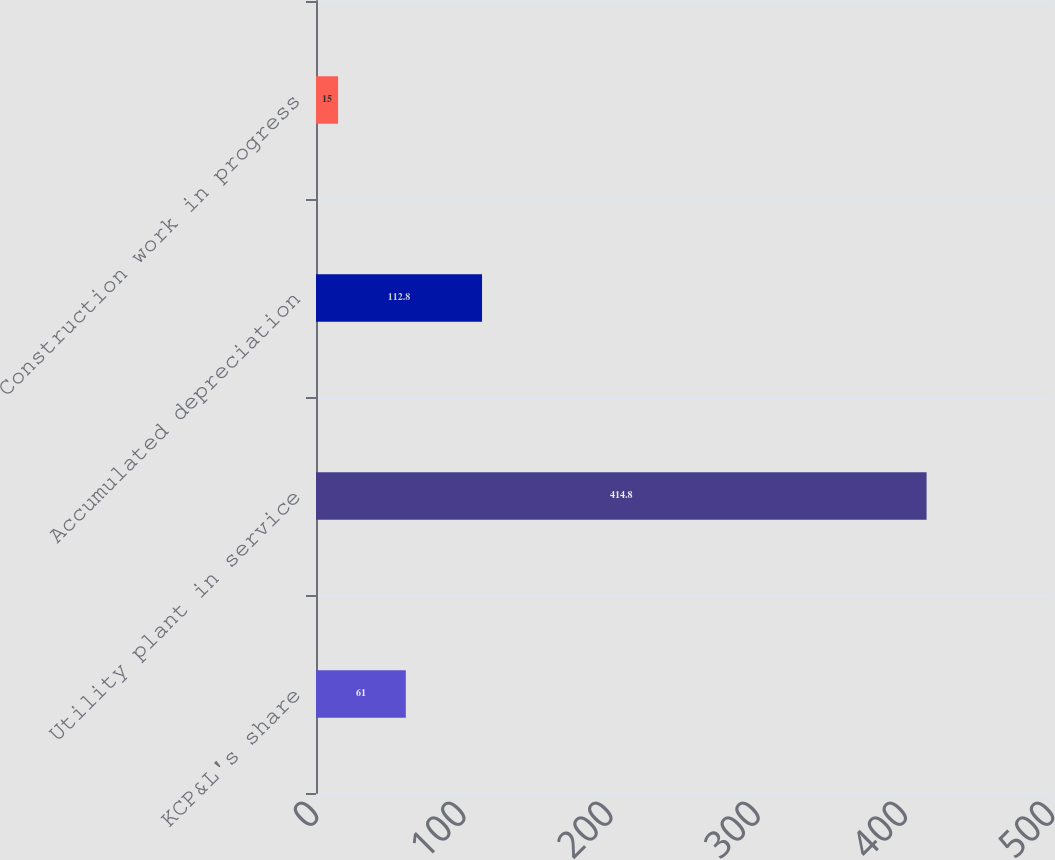<chart> <loc_0><loc_0><loc_500><loc_500><bar_chart><fcel>KCP&L's share<fcel>Utility plant in service<fcel>Accumulated depreciation<fcel>Construction work in progress<nl><fcel>61<fcel>414.8<fcel>112.8<fcel>15<nl></chart> 